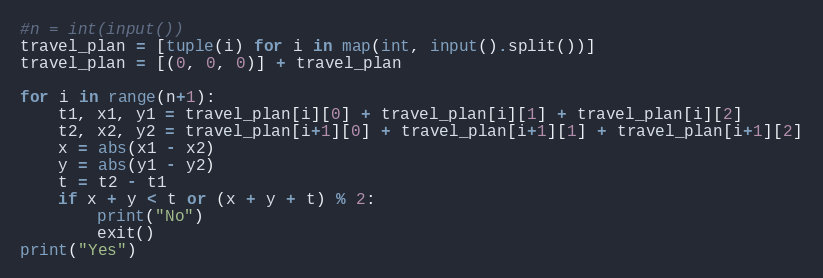Convert code to text. <code><loc_0><loc_0><loc_500><loc_500><_Python_>#n = int(input())
travel_plan = [tuple(i) for i in map(int, input().split())]
travel_plan = [(0, 0, 0)] + travel_plan

for i in range(n+1):
    t1, x1, y1 = travel_plan[i][0] + travel_plan[i][1] + travel_plan[i][2]
    t2, x2, y2 = travel_plan[i+1][0] + travel_plan[i+1][1] + travel_plan[i+1][2]
    x = abs(x1 - x2)
    y = abs(y1 - y2)
    t = t2 - t1
    if x + y < t or (x + y + t) % 2:
        print("No")
        exit()
print("Yes")</code> 